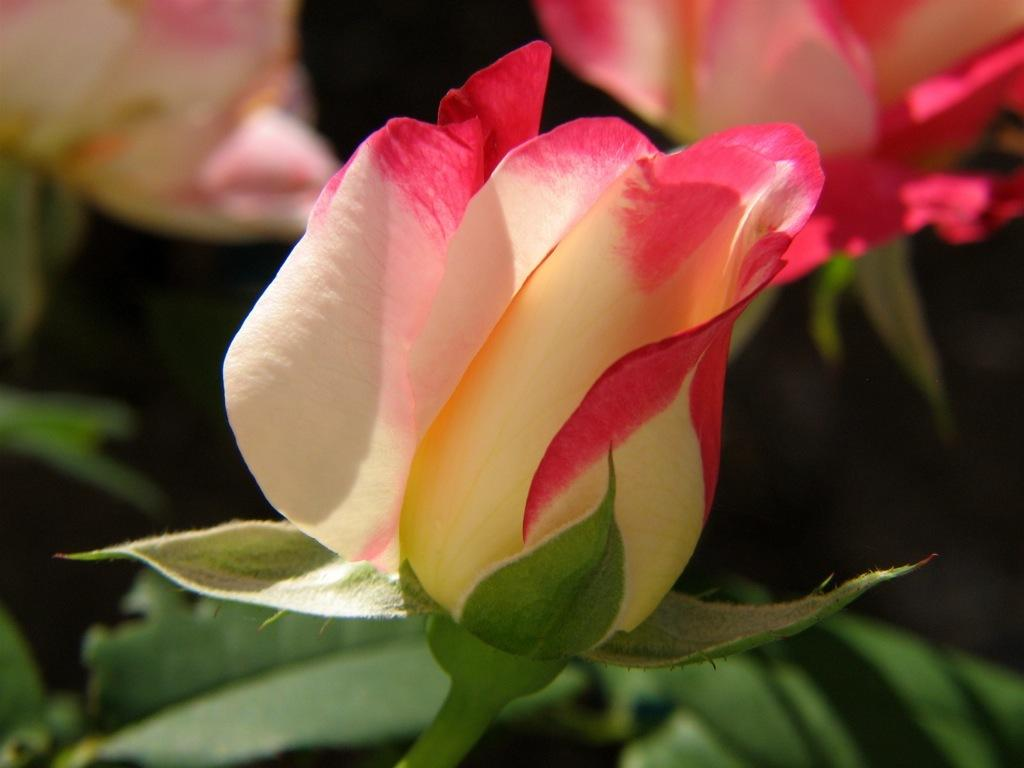What type of plants can be seen in the image? There are flowers and leaves in the image. What is the condition of the background in the image? The background of the image is blurry. What type of crate is visible in the image? There is no crate present in the image. What type of school can be seen in the background of the image? There is no school visible in the image, and the background is blurry. 